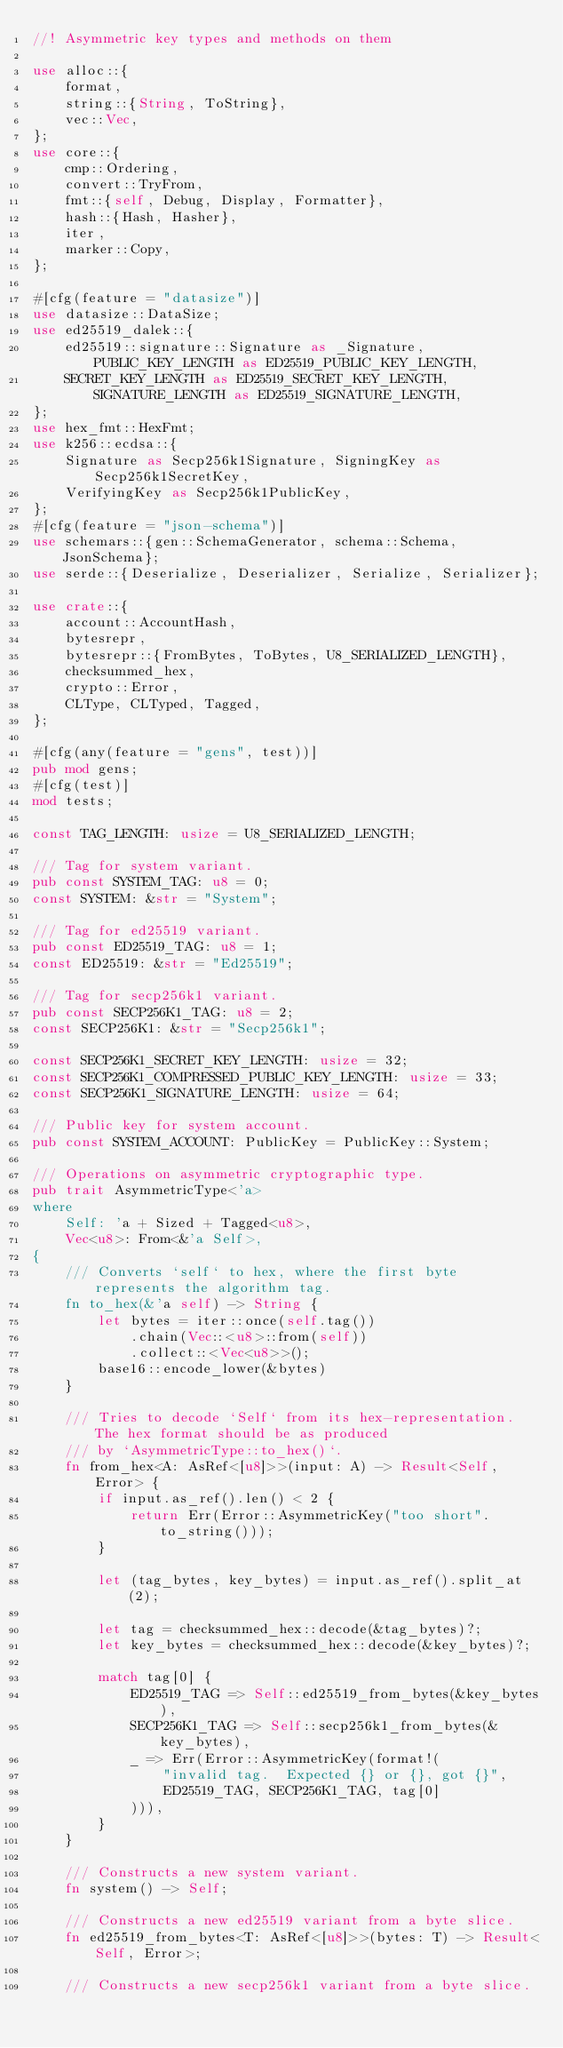<code> <loc_0><loc_0><loc_500><loc_500><_Rust_>//! Asymmetric key types and methods on them

use alloc::{
    format,
    string::{String, ToString},
    vec::Vec,
};
use core::{
    cmp::Ordering,
    convert::TryFrom,
    fmt::{self, Debug, Display, Formatter},
    hash::{Hash, Hasher},
    iter,
    marker::Copy,
};

#[cfg(feature = "datasize")]
use datasize::DataSize;
use ed25519_dalek::{
    ed25519::signature::Signature as _Signature, PUBLIC_KEY_LENGTH as ED25519_PUBLIC_KEY_LENGTH,
    SECRET_KEY_LENGTH as ED25519_SECRET_KEY_LENGTH, SIGNATURE_LENGTH as ED25519_SIGNATURE_LENGTH,
};
use hex_fmt::HexFmt;
use k256::ecdsa::{
    Signature as Secp256k1Signature, SigningKey as Secp256k1SecretKey,
    VerifyingKey as Secp256k1PublicKey,
};
#[cfg(feature = "json-schema")]
use schemars::{gen::SchemaGenerator, schema::Schema, JsonSchema};
use serde::{Deserialize, Deserializer, Serialize, Serializer};

use crate::{
    account::AccountHash,
    bytesrepr,
    bytesrepr::{FromBytes, ToBytes, U8_SERIALIZED_LENGTH},
    checksummed_hex,
    crypto::Error,
    CLType, CLTyped, Tagged,
};

#[cfg(any(feature = "gens", test))]
pub mod gens;
#[cfg(test)]
mod tests;

const TAG_LENGTH: usize = U8_SERIALIZED_LENGTH;

/// Tag for system variant.
pub const SYSTEM_TAG: u8 = 0;
const SYSTEM: &str = "System";

/// Tag for ed25519 variant.
pub const ED25519_TAG: u8 = 1;
const ED25519: &str = "Ed25519";

/// Tag for secp256k1 variant.
pub const SECP256K1_TAG: u8 = 2;
const SECP256K1: &str = "Secp256k1";

const SECP256K1_SECRET_KEY_LENGTH: usize = 32;
const SECP256K1_COMPRESSED_PUBLIC_KEY_LENGTH: usize = 33;
const SECP256K1_SIGNATURE_LENGTH: usize = 64;

/// Public key for system account.
pub const SYSTEM_ACCOUNT: PublicKey = PublicKey::System;

/// Operations on asymmetric cryptographic type.
pub trait AsymmetricType<'a>
where
    Self: 'a + Sized + Tagged<u8>,
    Vec<u8>: From<&'a Self>,
{
    /// Converts `self` to hex, where the first byte represents the algorithm tag.
    fn to_hex(&'a self) -> String {
        let bytes = iter::once(self.tag())
            .chain(Vec::<u8>::from(self))
            .collect::<Vec<u8>>();
        base16::encode_lower(&bytes)
    }

    /// Tries to decode `Self` from its hex-representation.  The hex format should be as produced
    /// by `AsymmetricType::to_hex()`.
    fn from_hex<A: AsRef<[u8]>>(input: A) -> Result<Self, Error> {
        if input.as_ref().len() < 2 {
            return Err(Error::AsymmetricKey("too short".to_string()));
        }

        let (tag_bytes, key_bytes) = input.as_ref().split_at(2);

        let tag = checksummed_hex::decode(&tag_bytes)?;
        let key_bytes = checksummed_hex::decode(&key_bytes)?;

        match tag[0] {
            ED25519_TAG => Self::ed25519_from_bytes(&key_bytes),
            SECP256K1_TAG => Self::secp256k1_from_bytes(&key_bytes),
            _ => Err(Error::AsymmetricKey(format!(
                "invalid tag.  Expected {} or {}, got {}",
                ED25519_TAG, SECP256K1_TAG, tag[0]
            ))),
        }
    }

    /// Constructs a new system variant.
    fn system() -> Self;

    /// Constructs a new ed25519 variant from a byte slice.
    fn ed25519_from_bytes<T: AsRef<[u8]>>(bytes: T) -> Result<Self, Error>;

    /// Constructs a new secp256k1 variant from a byte slice.</code> 